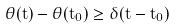<formula> <loc_0><loc_0><loc_500><loc_500>\theta ( t ) - \theta ( t _ { 0 } ) \geq \delta ( t - t _ { 0 } )</formula> 